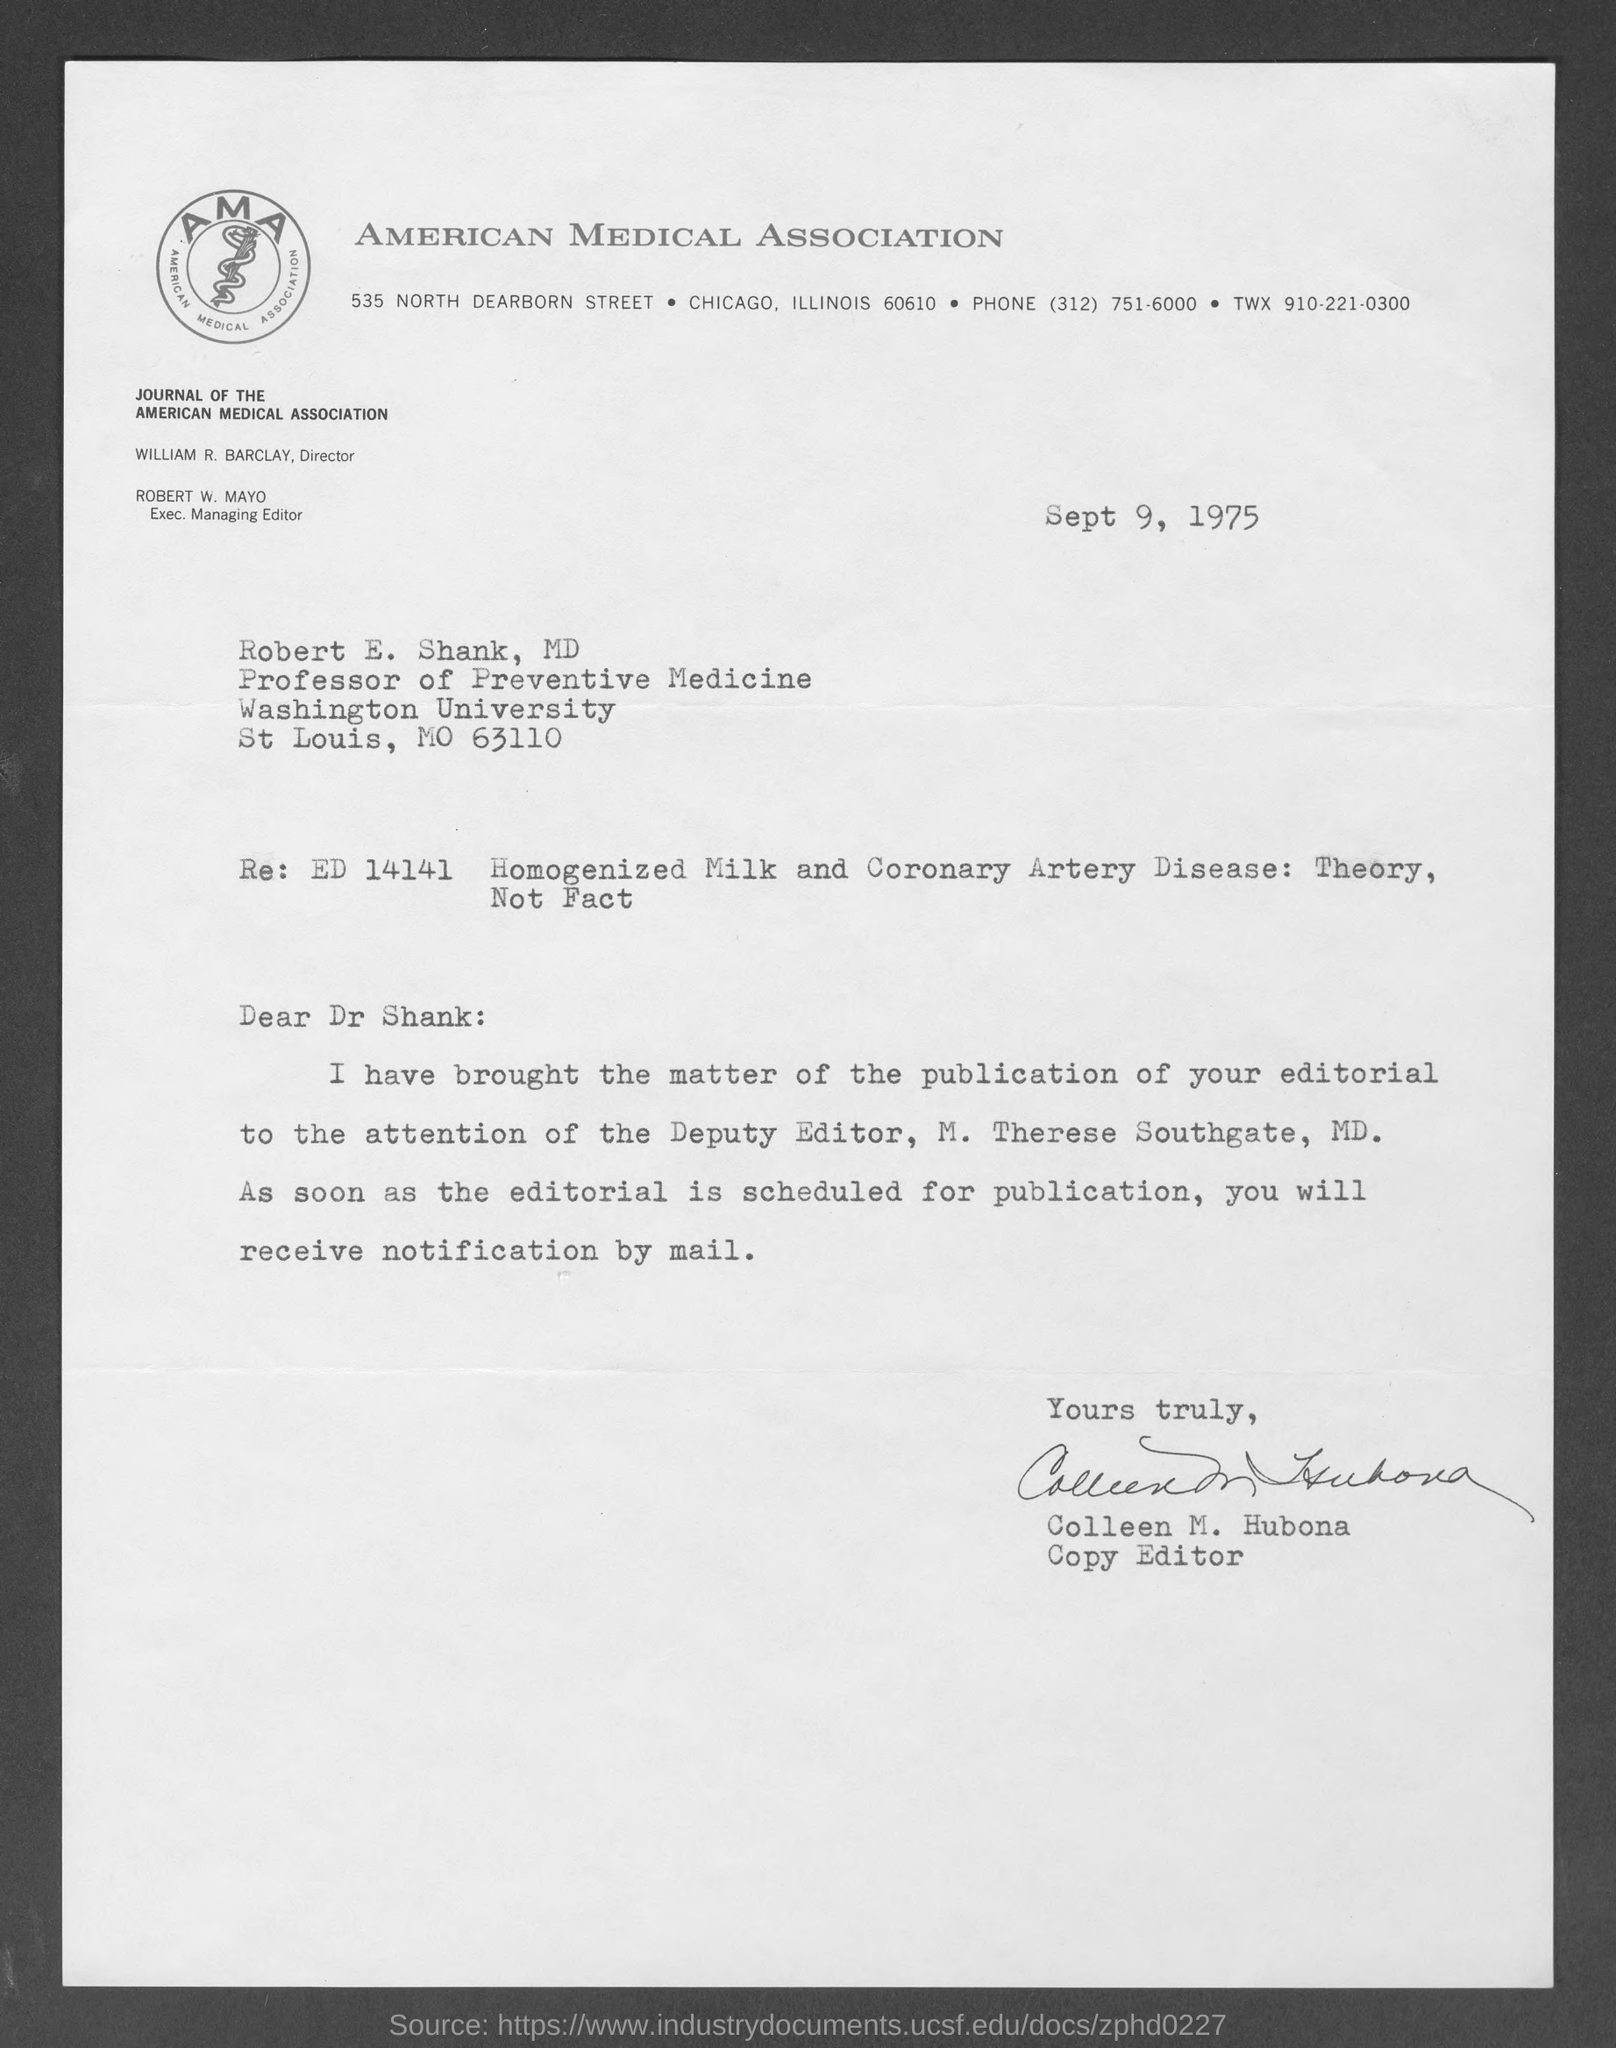Identify some key points in this picture. The document has been signed by Colleen M. Hubona. Colleen M. Hubona is designated as a Copy Editor. The designation of M. Therese Southgate, MD., is Deputy Editor. Robert W. Mayo holds the designation of Executive Managing Editor. The date mentioned in this letter is September 9, 1975. 